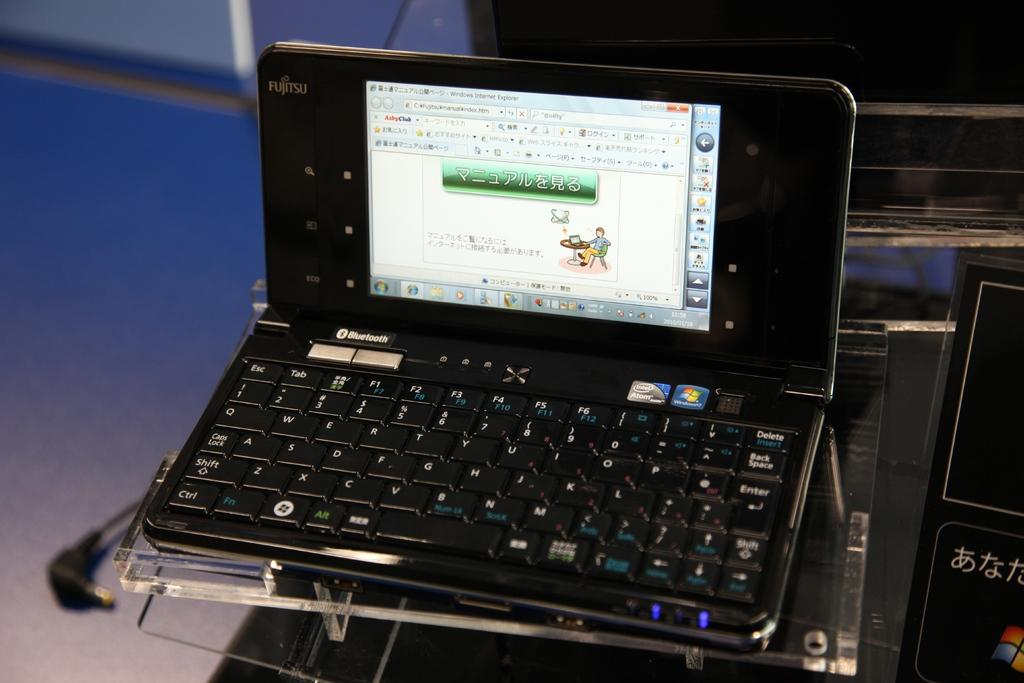<image>
Give a short and clear explanation of the subsequent image. A laptop powered with an intel atom processor and has bluetooth ability. 